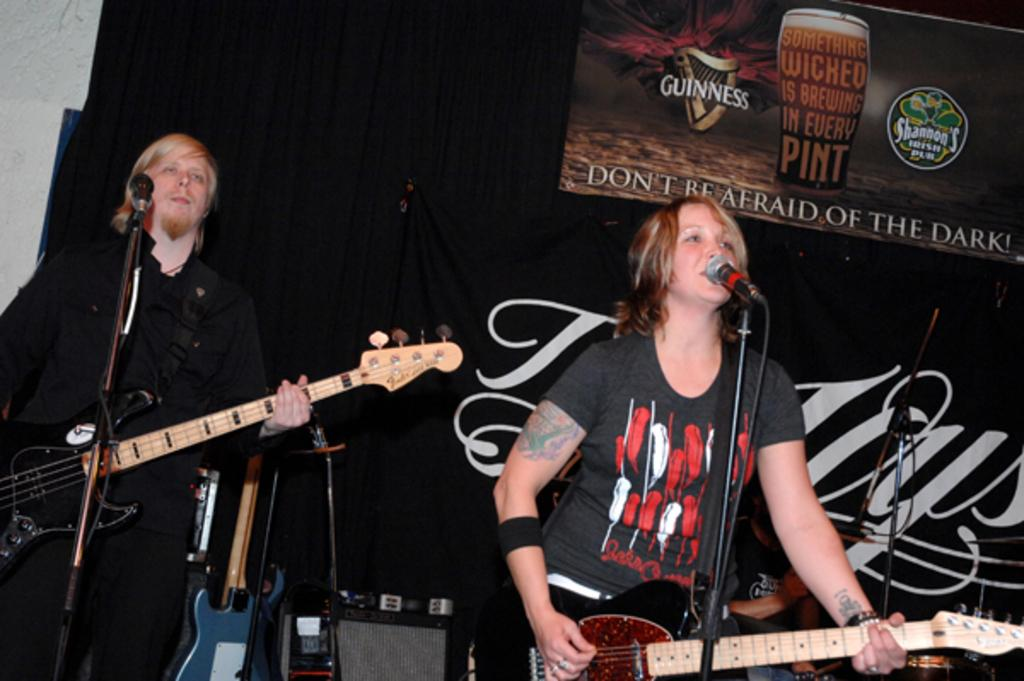What is the man in the image doing? The man is playing a guitar in the image. What is the man's position in relation to the microphone? The man is in front of a microphone in the image. What is the woman in the image doing? The woman is playing a guitar and singing a song in the image. What is the woman's position in relation to the microphone? The woman is in front of a microphone in the image. Can you see any boats in the image? No, there are no boats present in the image. What type of seed is the woman using to play the guitar? The woman is not using any seed to play the guitar; she is using her hands. 